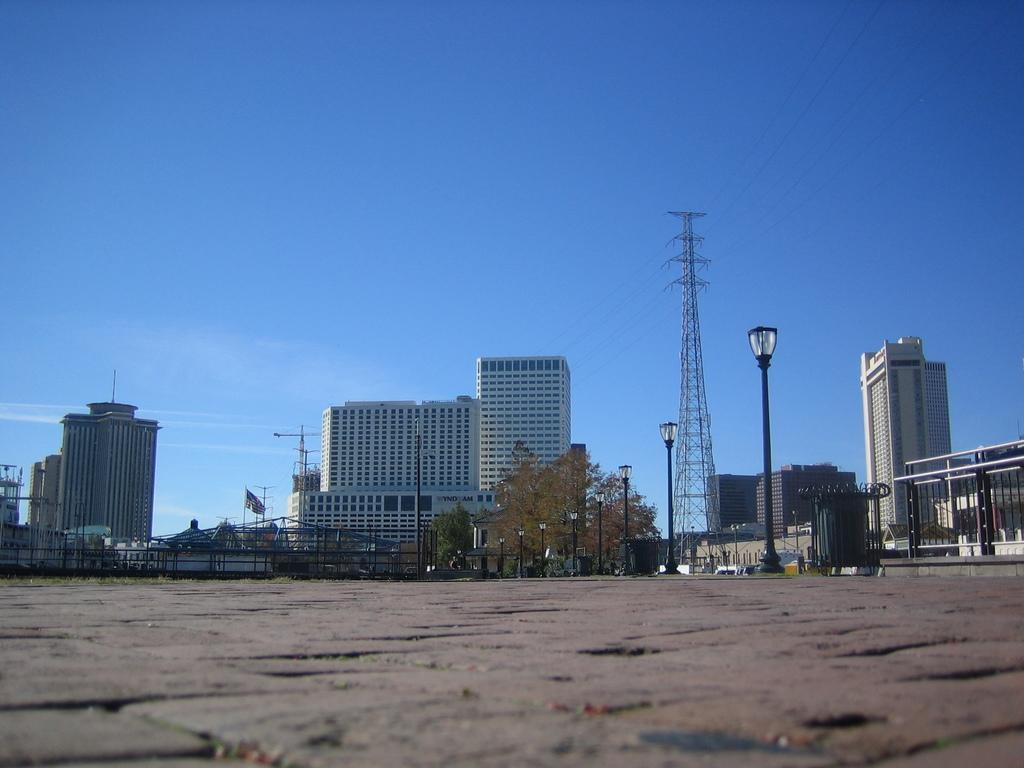What type of location is depicted in the image? The image shows an open area. What can be seen in the background of the image? There are lights, trees, a tower, and buildings visible in the background. What is the condition of the sky in the image? The sky is clear and visible at the top of the image. How does the crowd react to the committee's decision in the image? There is no crowd or committee present in the image; it shows an open area with lights, trees, a tower, and buildings in the background. 